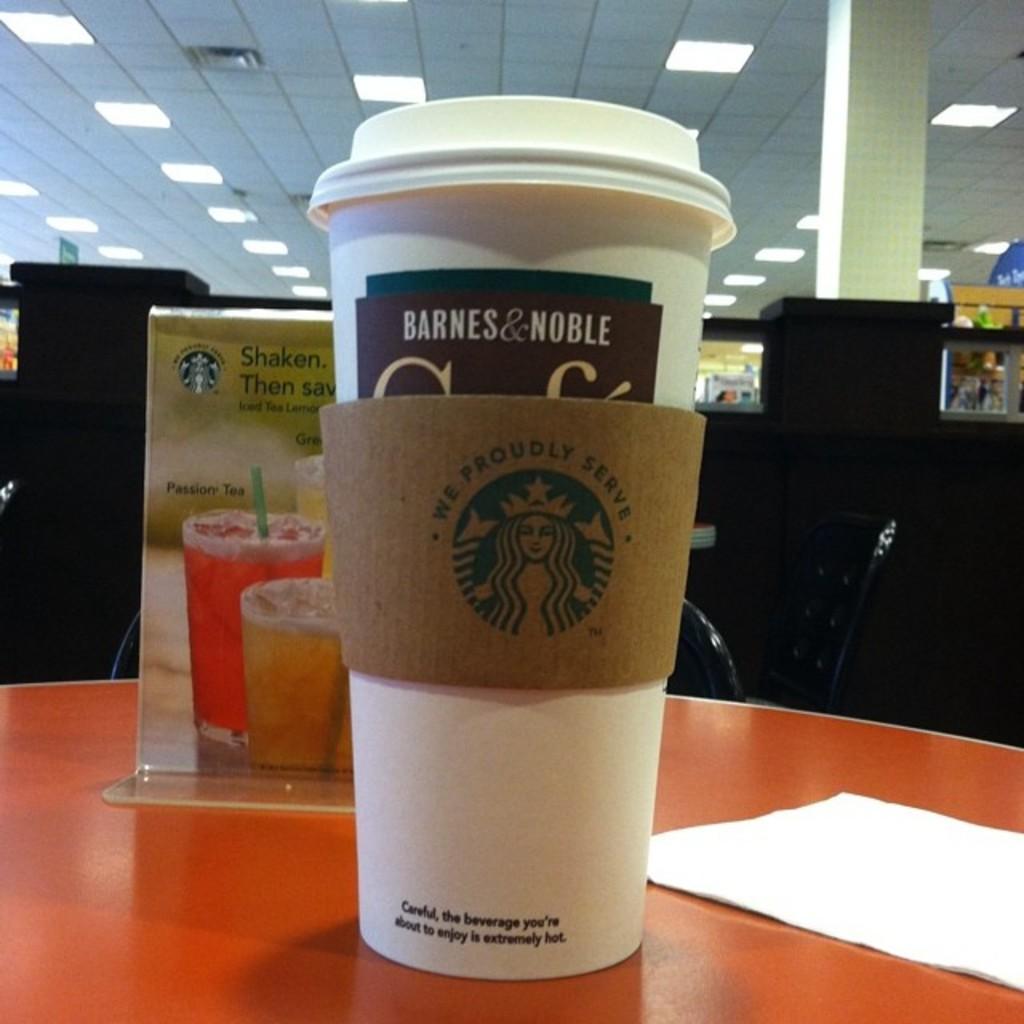In one or two sentences, can you explain what this image depicts? In this image there is a table towards the bottom of the image, there are objects on the table, there is a chair, there are objects towards the right of the image, there are objects towards the left of the image, there is a pillar towards the top of the image, there is a roof towards the top of the image, there are lights. 